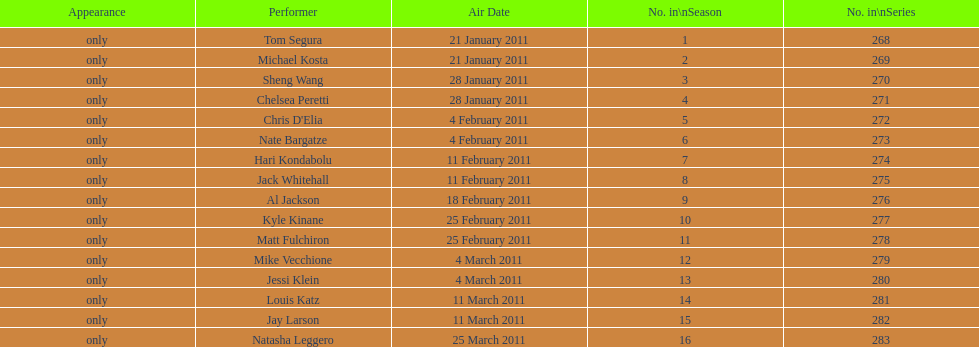Did al jackson air before or after kyle kinane? Before. Would you be able to parse every entry in this table? {'header': ['Appearance', 'Performer', 'Air Date', 'No. in\\nSeason', 'No. in\\nSeries'], 'rows': [['only', 'Tom Segura', '21 January 2011', '1', '268'], ['only', 'Michael Kosta', '21 January 2011', '2', '269'], ['only', 'Sheng Wang', '28 January 2011', '3', '270'], ['only', 'Chelsea Peretti', '28 January 2011', '4', '271'], ['only', "Chris D'Elia", '4 February 2011', '5', '272'], ['only', 'Nate Bargatze', '4 February 2011', '6', '273'], ['only', 'Hari Kondabolu', '11 February 2011', '7', '274'], ['only', 'Jack Whitehall', '11 February 2011', '8', '275'], ['only', 'Al Jackson', '18 February 2011', '9', '276'], ['only', 'Kyle Kinane', '25 February 2011', '10', '277'], ['only', 'Matt Fulchiron', '25 February 2011', '11', '278'], ['only', 'Mike Vecchione', '4 March 2011', '12', '279'], ['only', 'Jessi Klein', '4 March 2011', '13', '280'], ['only', 'Louis Katz', '11 March 2011', '14', '281'], ['only', 'Jay Larson', '11 March 2011', '15', '282'], ['only', 'Natasha Leggero', '25 March 2011', '16', '283']]} 